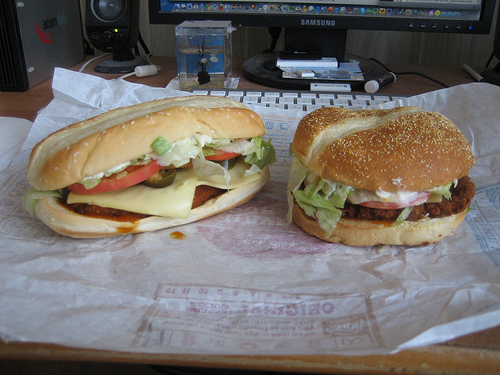Please provide a short description for this region: [0.3, 0.39, 0.35, 0.43]. A slice of provolone cheese peeking out from the bun of a hamburger, creating a delectable, cheesy appeal. 